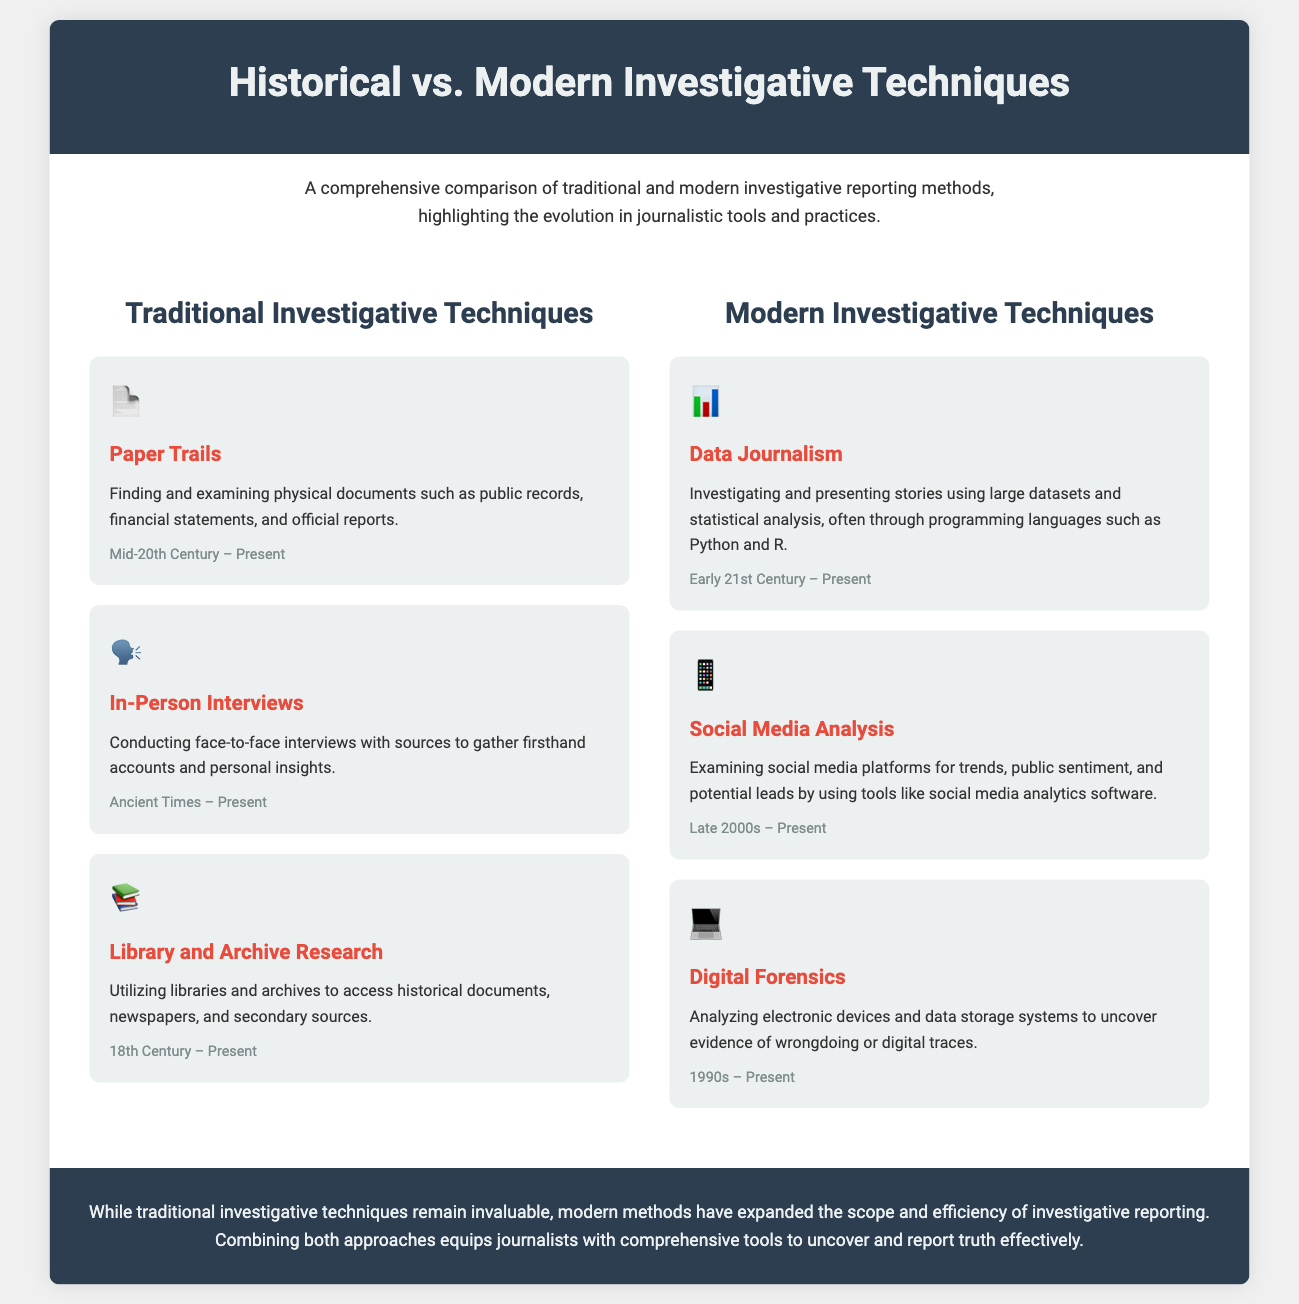What is the primary focus of the infographic? The infographic compares traditional and modern investigative reporting methods, highlighting the evolution in journalistic tools and practices.
Answer: Comparison of investigative methods What symbol represents "Data Journalism"? The document uses an icon to represent each technique; "Data Journalism" is represented by the icon for data visualization.
Answer: 📊 When did "In-Person Interviews" originate? The timeline for "In-Person Interviews" indicates they have been used since ancient times, showing their long-standing relevance.
Answer: Ancient Times What is the latest modern investigative technique mentioned? The document lists multiple modern techniques, with "Digital Forensics" as the last mentioned in the modern section.
Answer: Digital Forensics Which investigative method has its timeline starting in the 18th Century? The timeline for "Library and Archive Research" begins in the 18th Century, highlighting its historical context.
Answer: Library and Archive Research What is the time period for "Social Media Analysis"? According to the timeline provided, "Social Media Analysis" began in the late 2000s and is still in use today.
Answer: Late 2000s – Present What color is the header background? The header background color is highlighted in the style section of the document, specified as dark blue.
Answer: Dark blue Which technique involves programming languages such as Python and R? The description for "Data Journalism" specifies the use of programming languages for data analysis in investigative reporting.
Answer: Data Journalism 